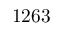<formula> <loc_0><loc_0><loc_500><loc_500>1 2 6 3</formula> 